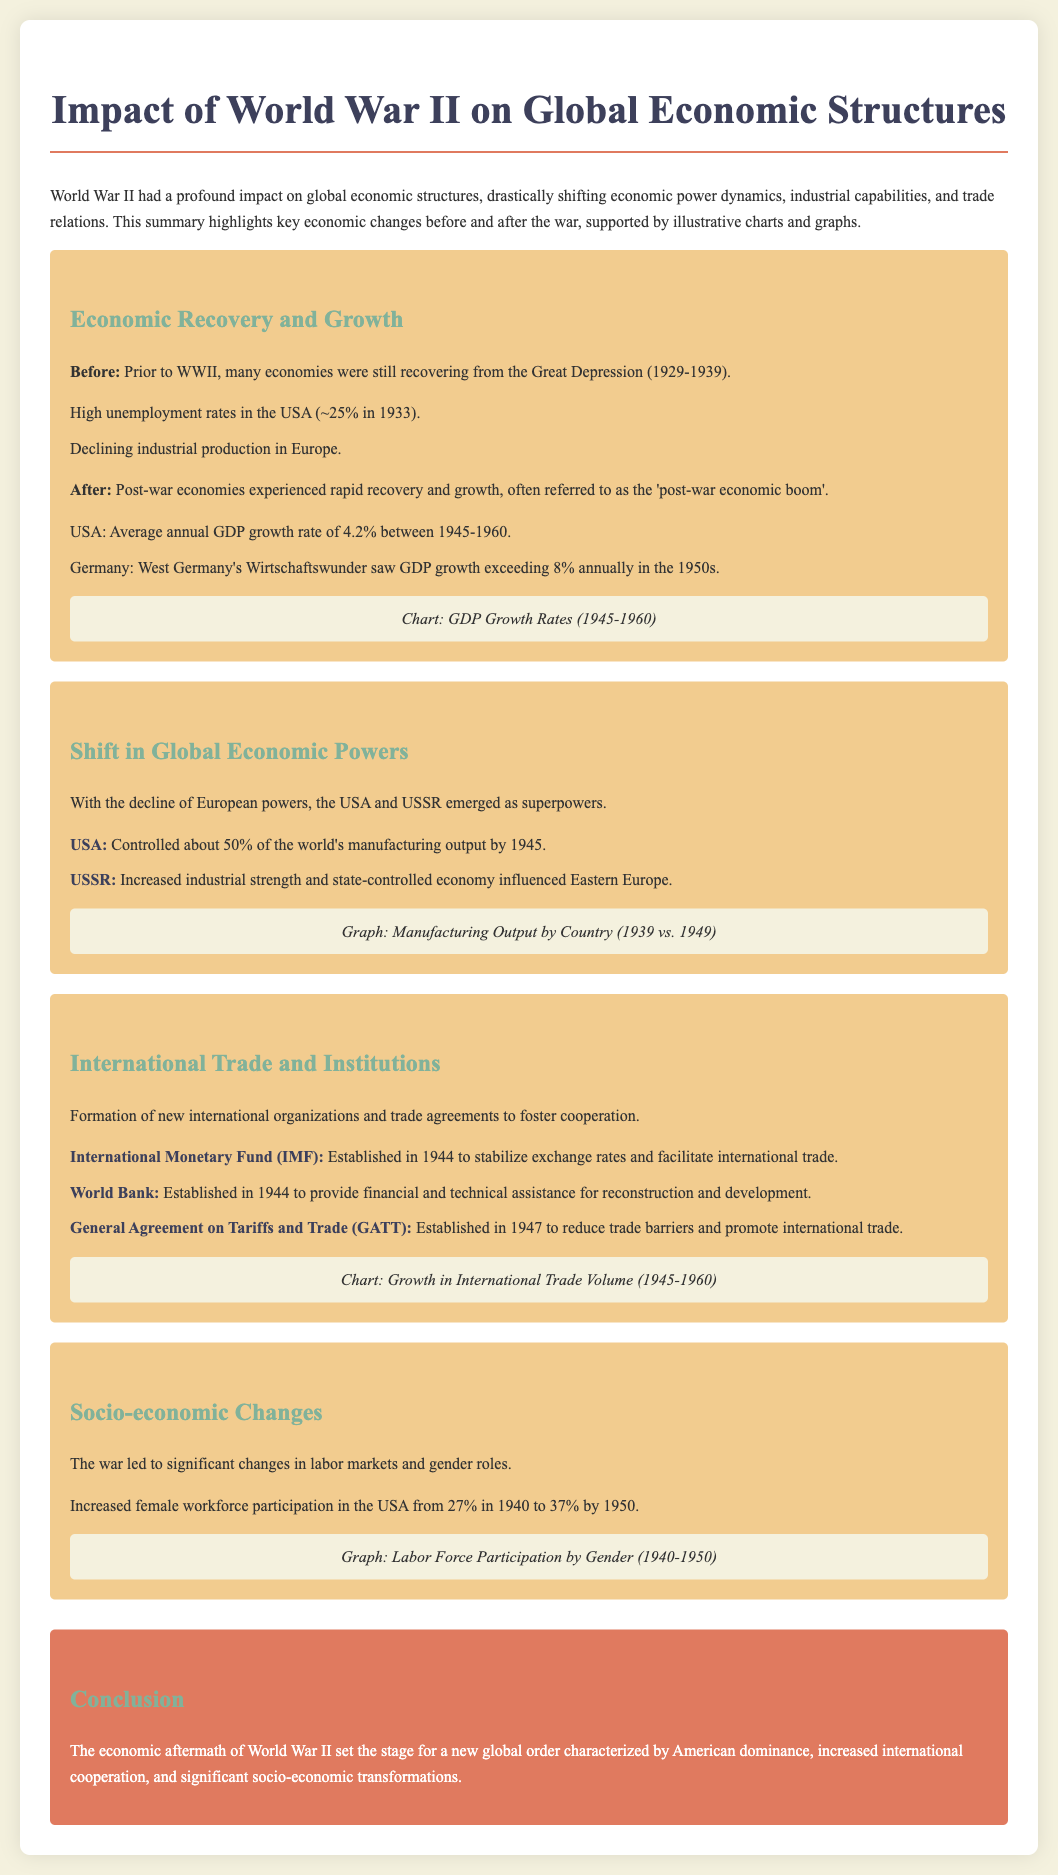What was the average annual GDP growth rate in the USA between 1945-1960? The average annual GDP growth rate for the USA during this period is highlighted in the 'Economic Recovery and Growth' section of the document.
Answer: 4.2% What was the GDP growth rate of West Germany in the 1950s? The document states that West Germany's GDP growth exceeded 8% annually during this decade.
Answer: 8% What organization was established in 1944 to stabilize exchange rates? The document mentions the International Monetary Fund (IMF) established in 1944 for this purpose.
Answer: International Monetary Fund What was the percentage of female workforce participation in the USA in 1950? The document provides statistics regarding female workforce participation increase by 1950.
Answer: 37% Which two countries emerged as superpowers after WWII? The document discusses the shift in global economic powers, specifically mentioning the USA and USSR.
Answer: USA and USSR What significant change occurred in female workforce participation from 1940 to 1950 in the USA? The document notes the increase in female workforce participation during this period.
Answer: Increased from 27% to 37% What two international organizations were established alongside the IMF in 1944? The document lists other organizations established in 1944, alongside the IMF.
Answer: World Bank and IMF What major economic phenomenon is referred to as the 'post-war economic boom'? The document describes the significant recovery and growth of economies post-WWII using this term.
Answer: post-war economic boom 